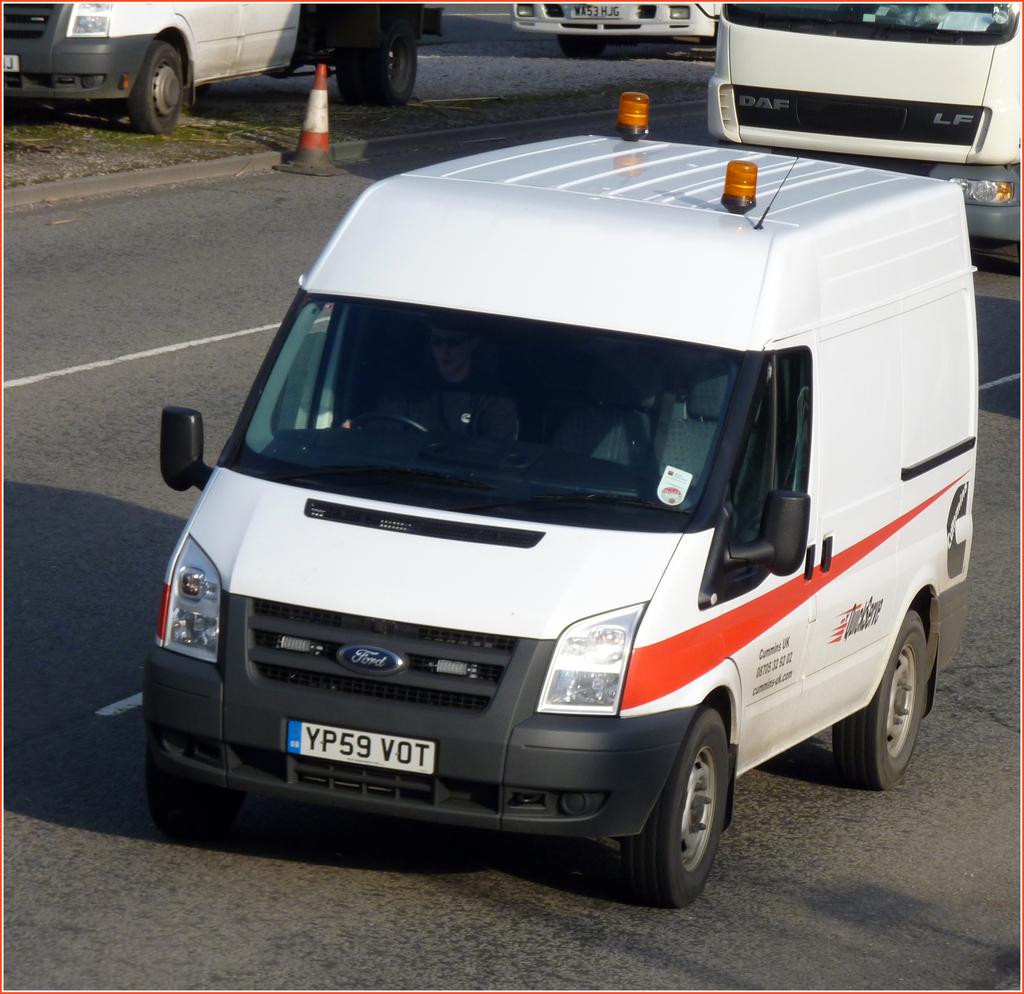What does the license plate say?
Your answer should be very brief. Yp59 vot. 